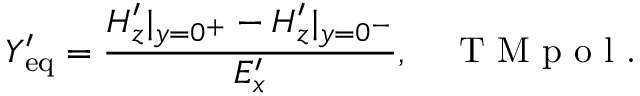<formula> <loc_0><loc_0><loc_500><loc_500>Y _ { e q } ^ { \prime } = \frac { H _ { z } ^ { \prime } | _ { y = 0 ^ { + } } - H _ { z } ^ { \prime } | _ { y = 0 ^ { - } } } { E _ { x } ^ { \prime } } , \quad T M p o l .</formula> 